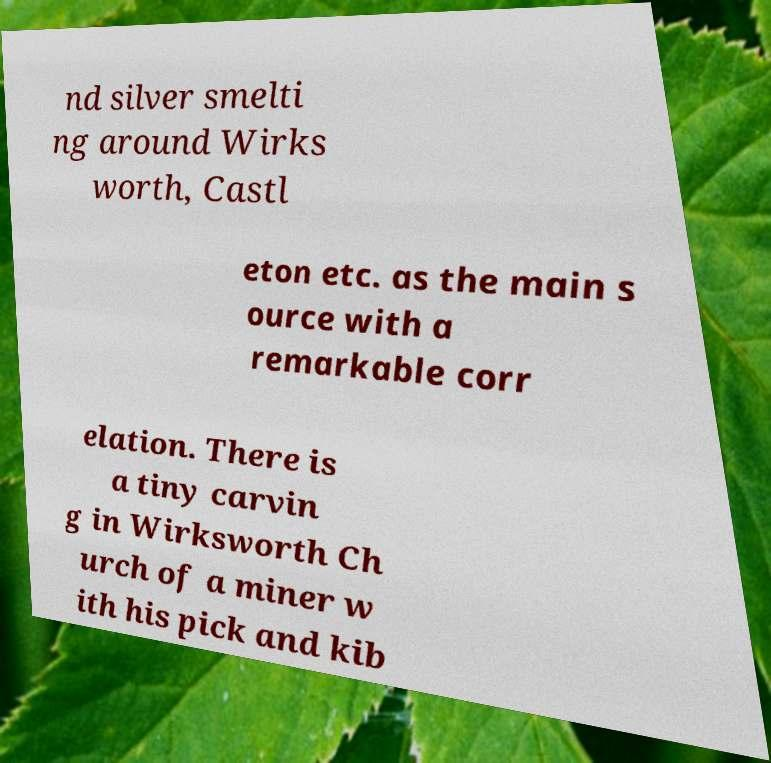Could you extract and type out the text from this image? nd silver smelti ng around Wirks worth, Castl eton etc. as the main s ource with a remarkable corr elation. There is a tiny carvin g in Wirksworth Ch urch of a miner w ith his pick and kib 